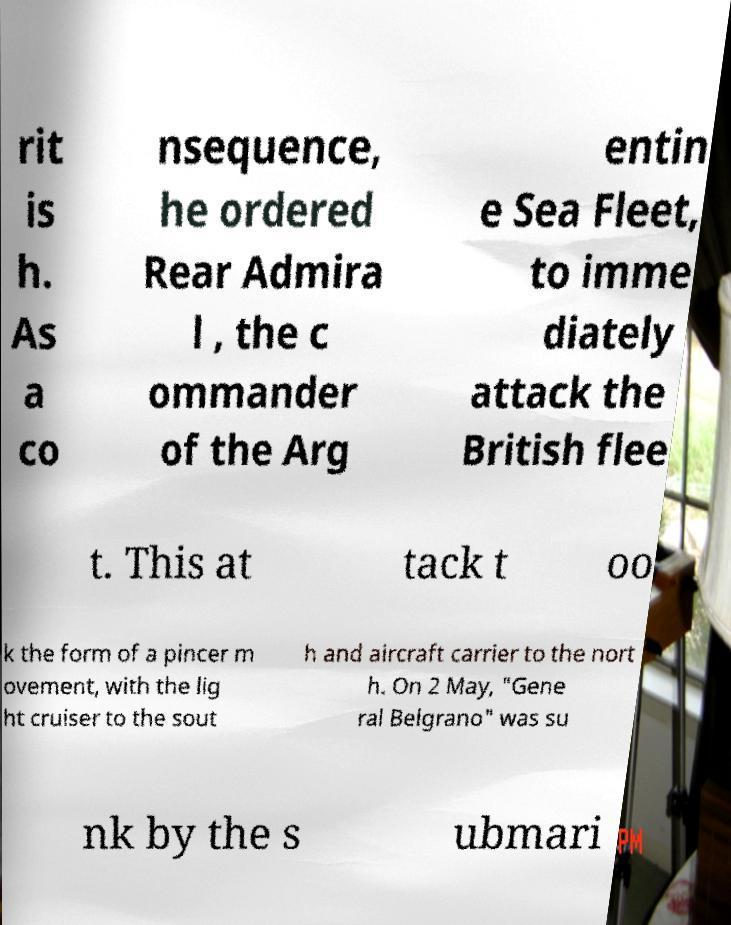There's text embedded in this image that I need extracted. Can you transcribe it verbatim? rit is h. As a co nsequence, he ordered Rear Admira l , the c ommander of the Arg entin e Sea Fleet, to imme diately attack the British flee t. This at tack t oo k the form of a pincer m ovement, with the lig ht cruiser to the sout h and aircraft carrier to the nort h. On 2 May, "Gene ral Belgrano" was su nk by the s ubmari 